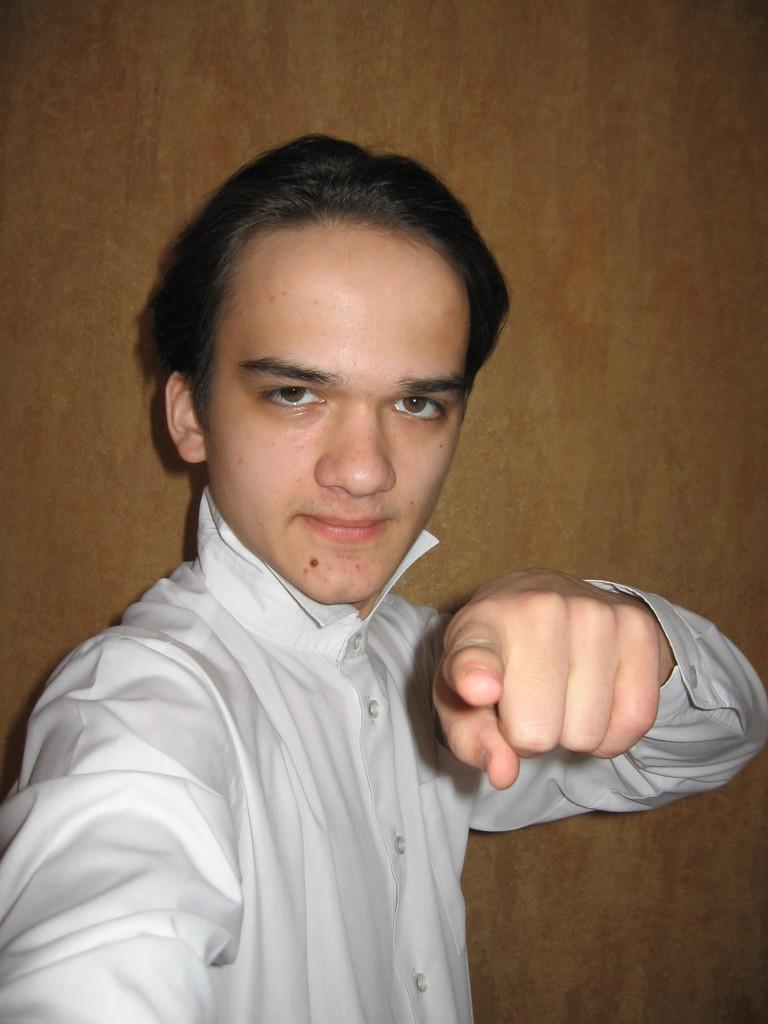Who is present in the image? There is a man in the image. What is the man wearing? The man is wearing a white shirt. What can be seen behind the man in the image? There is a brown color wall in the image. What type of stone can be seen in the image? There is no stone present in the image. Is there a tub visible in the image? No, there is no tub present in the image. 